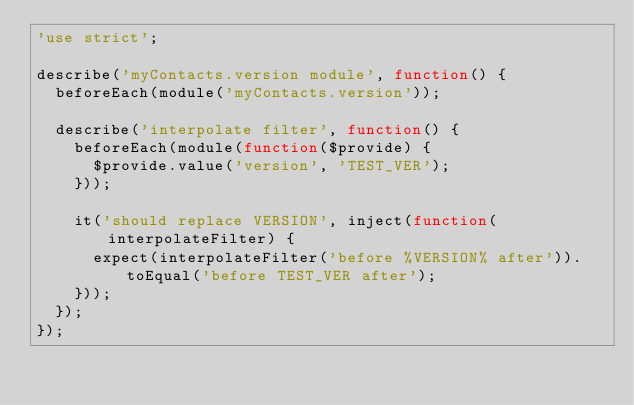Convert code to text. <code><loc_0><loc_0><loc_500><loc_500><_JavaScript_>'use strict';

describe('myContacts.version module', function() {
  beforeEach(module('myContacts.version'));

  describe('interpolate filter', function() {
    beforeEach(module(function($provide) {
      $provide.value('version', 'TEST_VER');
    }));

    it('should replace VERSION', inject(function(interpolateFilter) {
      expect(interpolateFilter('before %VERSION% after')).toEqual('before TEST_VER after');
    }));
  });
});
</code> 